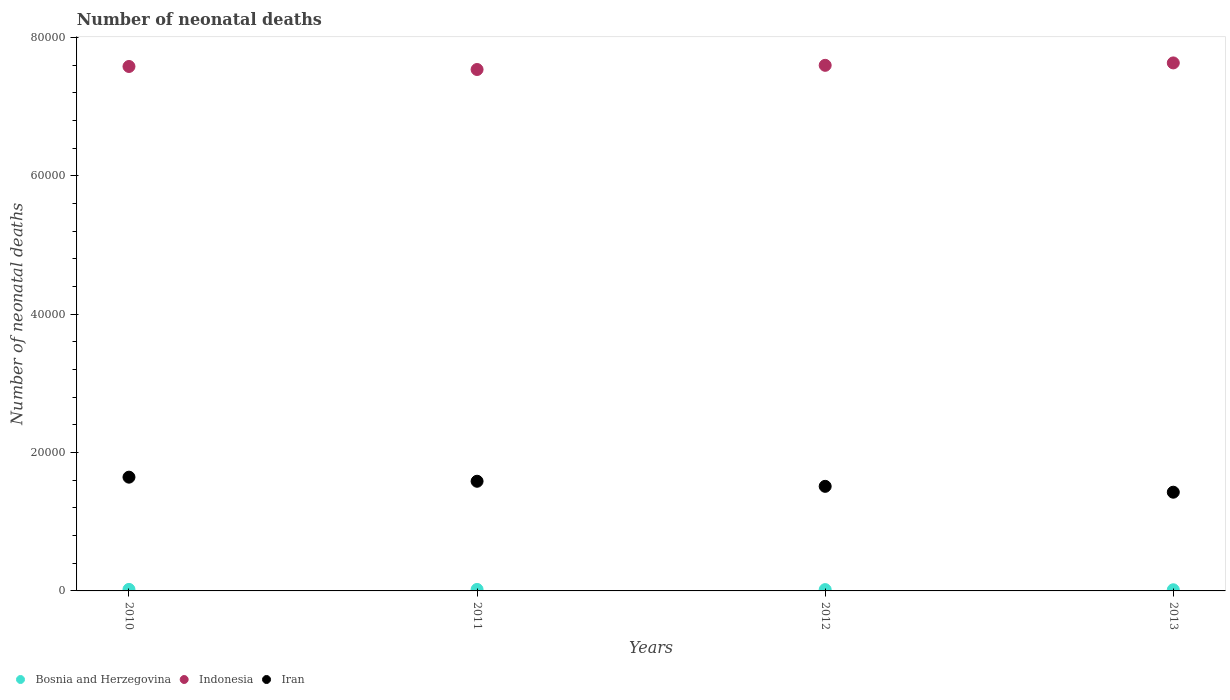How many different coloured dotlines are there?
Provide a succinct answer. 3. What is the number of neonatal deaths in in Iran in 2012?
Offer a terse response. 1.51e+04. Across all years, what is the maximum number of neonatal deaths in in Iran?
Make the answer very short. 1.64e+04. Across all years, what is the minimum number of neonatal deaths in in Iran?
Keep it short and to the point. 1.43e+04. In which year was the number of neonatal deaths in in Iran minimum?
Provide a succinct answer. 2013. What is the total number of neonatal deaths in in Iran in the graph?
Ensure brevity in your answer.  6.17e+04. What is the difference between the number of neonatal deaths in in Iran in 2010 and that in 2013?
Your answer should be very brief. 2174. What is the difference between the number of neonatal deaths in in Bosnia and Herzegovina in 2011 and the number of neonatal deaths in in Iran in 2012?
Provide a succinct answer. -1.49e+04. What is the average number of neonatal deaths in in Bosnia and Herzegovina per year?
Provide a succinct answer. 198.5. In the year 2012, what is the difference between the number of neonatal deaths in in Indonesia and number of neonatal deaths in in Bosnia and Herzegovina?
Ensure brevity in your answer.  7.58e+04. In how many years, is the number of neonatal deaths in in Indonesia greater than 48000?
Offer a very short reply. 4. What is the ratio of the number of neonatal deaths in in Indonesia in 2011 to that in 2012?
Your answer should be very brief. 0.99. Is the number of neonatal deaths in in Bosnia and Herzegovina in 2010 less than that in 2012?
Your answer should be very brief. No. What is the difference between the highest and the second highest number of neonatal deaths in in Iran?
Your answer should be very brief. 592. What is the difference between the highest and the lowest number of neonatal deaths in in Indonesia?
Your answer should be compact. 951. In how many years, is the number of neonatal deaths in in Indonesia greater than the average number of neonatal deaths in in Indonesia taken over all years?
Offer a very short reply. 2. Is the sum of the number of neonatal deaths in in Bosnia and Herzegovina in 2012 and 2013 greater than the maximum number of neonatal deaths in in Iran across all years?
Ensure brevity in your answer.  No. Is it the case that in every year, the sum of the number of neonatal deaths in in Bosnia and Herzegovina and number of neonatal deaths in in Indonesia  is greater than the number of neonatal deaths in in Iran?
Keep it short and to the point. Yes. Is the number of neonatal deaths in in Bosnia and Herzegovina strictly greater than the number of neonatal deaths in in Indonesia over the years?
Ensure brevity in your answer.  No. How many years are there in the graph?
Offer a terse response. 4. What is the difference between two consecutive major ticks on the Y-axis?
Provide a succinct answer. 2.00e+04. Are the values on the major ticks of Y-axis written in scientific E-notation?
Ensure brevity in your answer.  No. Where does the legend appear in the graph?
Keep it short and to the point. Bottom left. How many legend labels are there?
Offer a terse response. 3. What is the title of the graph?
Provide a succinct answer. Number of neonatal deaths. What is the label or title of the X-axis?
Your response must be concise. Years. What is the label or title of the Y-axis?
Offer a terse response. Number of neonatal deaths. What is the Number of neonatal deaths of Bosnia and Herzegovina in 2010?
Your response must be concise. 220. What is the Number of neonatal deaths of Indonesia in 2010?
Your answer should be very brief. 7.58e+04. What is the Number of neonatal deaths of Iran in 2010?
Your answer should be very brief. 1.64e+04. What is the Number of neonatal deaths in Bosnia and Herzegovina in 2011?
Provide a succinct answer. 215. What is the Number of neonatal deaths of Indonesia in 2011?
Provide a succinct answer. 7.54e+04. What is the Number of neonatal deaths in Iran in 2011?
Make the answer very short. 1.58e+04. What is the Number of neonatal deaths of Bosnia and Herzegovina in 2012?
Keep it short and to the point. 192. What is the Number of neonatal deaths of Indonesia in 2012?
Ensure brevity in your answer.  7.60e+04. What is the Number of neonatal deaths in Iran in 2012?
Provide a short and direct response. 1.51e+04. What is the Number of neonatal deaths in Bosnia and Herzegovina in 2013?
Your answer should be compact. 167. What is the Number of neonatal deaths of Indonesia in 2013?
Ensure brevity in your answer.  7.63e+04. What is the Number of neonatal deaths in Iran in 2013?
Keep it short and to the point. 1.43e+04. Across all years, what is the maximum Number of neonatal deaths of Bosnia and Herzegovina?
Provide a short and direct response. 220. Across all years, what is the maximum Number of neonatal deaths in Indonesia?
Ensure brevity in your answer.  7.63e+04. Across all years, what is the maximum Number of neonatal deaths of Iran?
Offer a very short reply. 1.64e+04. Across all years, what is the minimum Number of neonatal deaths of Bosnia and Herzegovina?
Ensure brevity in your answer.  167. Across all years, what is the minimum Number of neonatal deaths of Indonesia?
Provide a short and direct response. 7.54e+04. Across all years, what is the minimum Number of neonatal deaths of Iran?
Give a very brief answer. 1.43e+04. What is the total Number of neonatal deaths in Bosnia and Herzegovina in the graph?
Ensure brevity in your answer.  794. What is the total Number of neonatal deaths of Indonesia in the graph?
Your response must be concise. 3.03e+05. What is the total Number of neonatal deaths of Iran in the graph?
Ensure brevity in your answer.  6.17e+04. What is the difference between the Number of neonatal deaths of Indonesia in 2010 and that in 2011?
Offer a very short reply. 436. What is the difference between the Number of neonatal deaths of Iran in 2010 and that in 2011?
Ensure brevity in your answer.  592. What is the difference between the Number of neonatal deaths of Indonesia in 2010 and that in 2012?
Your answer should be compact. -167. What is the difference between the Number of neonatal deaths in Iran in 2010 and that in 2012?
Provide a short and direct response. 1326. What is the difference between the Number of neonatal deaths of Indonesia in 2010 and that in 2013?
Ensure brevity in your answer.  -515. What is the difference between the Number of neonatal deaths of Iran in 2010 and that in 2013?
Provide a short and direct response. 2174. What is the difference between the Number of neonatal deaths of Indonesia in 2011 and that in 2012?
Offer a very short reply. -603. What is the difference between the Number of neonatal deaths of Iran in 2011 and that in 2012?
Offer a terse response. 734. What is the difference between the Number of neonatal deaths in Bosnia and Herzegovina in 2011 and that in 2013?
Make the answer very short. 48. What is the difference between the Number of neonatal deaths of Indonesia in 2011 and that in 2013?
Your response must be concise. -951. What is the difference between the Number of neonatal deaths of Iran in 2011 and that in 2013?
Ensure brevity in your answer.  1582. What is the difference between the Number of neonatal deaths in Bosnia and Herzegovina in 2012 and that in 2013?
Ensure brevity in your answer.  25. What is the difference between the Number of neonatal deaths of Indonesia in 2012 and that in 2013?
Offer a terse response. -348. What is the difference between the Number of neonatal deaths of Iran in 2012 and that in 2013?
Provide a succinct answer. 848. What is the difference between the Number of neonatal deaths in Bosnia and Herzegovina in 2010 and the Number of neonatal deaths in Indonesia in 2011?
Make the answer very short. -7.51e+04. What is the difference between the Number of neonatal deaths of Bosnia and Herzegovina in 2010 and the Number of neonatal deaths of Iran in 2011?
Your answer should be compact. -1.56e+04. What is the difference between the Number of neonatal deaths of Indonesia in 2010 and the Number of neonatal deaths of Iran in 2011?
Your response must be concise. 5.99e+04. What is the difference between the Number of neonatal deaths in Bosnia and Herzegovina in 2010 and the Number of neonatal deaths in Indonesia in 2012?
Keep it short and to the point. -7.57e+04. What is the difference between the Number of neonatal deaths of Bosnia and Herzegovina in 2010 and the Number of neonatal deaths of Iran in 2012?
Offer a terse response. -1.49e+04. What is the difference between the Number of neonatal deaths in Indonesia in 2010 and the Number of neonatal deaths in Iran in 2012?
Give a very brief answer. 6.07e+04. What is the difference between the Number of neonatal deaths in Bosnia and Herzegovina in 2010 and the Number of neonatal deaths in Indonesia in 2013?
Ensure brevity in your answer.  -7.61e+04. What is the difference between the Number of neonatal deaths of Bosnia and Herzegovina in 2010 and the Number of neonatal deaths of Iran in 2013?
Offer a terse response. -1.40e+04. What is the difference between the Number of neonatal deaths of Indonesia in 2010 and the Number of neonatal deaths of Iran in 2013?
Keep it short and to the point. 6.15e+04. What is the difference between the Number of neonatal deaths in Bosnia and Herzegovina in 2011 and the Number of neonatal deaths in Indonesia in 2012?
Offer a very short reply. -7.57e+04. What is the difference between the Number of neonatal deaths of Bosnia and Herzegovina in 2011 and the Number of neonatal deaths of Iran in 2012?
Make the answer very short. -1.49e+04. What is the difference between the Number of neonatal deaths in Indonesia in 2011 and the Number of neonatal deaths in Iran in 2012?
Your answer should be very brief. 6.02e+04. What is the difference between the Number of neonatal deaths in Bosnia and Herzegovina in 2011 and the Number of neonatal deaths in Indonesia in 2013?
Your answer should be compact. -7.61e+04. What is the difference between the Number of neonatal deaths of Bosnia and Herzegovina in 2011 and the Number of neonatal deaths of Iran in 2013?
Ensure brevity in your answer.  -1.41e+04. What is the difference between the Number of neonatal deaths of Indonesia in 2011 and the Number of neonatal deaths of Iran in 2013?
Provide a succinct answer. 6.11e+04. What is the difference between the Number of neonatal deaths in Bosnia and Herzegovina in 2012 and the Number of neonatal deaths in Indonesia in 2013?
Offer a terse response. -7.61e+04. What is the difference between the Number of neonatal deaths in Bosnia and Herzegovina in 2012 and the Number of neonatal deaths in Iran in 2013?
Keep it short and to the point. -1.41e+04. What is the difference between the Number of neonatal deaths in Indonesia in 2012 and the Number of neonatal deaths in Iran in 2013?
Keep it short and to the point. 6.17e+04. What is the average Number of neonatal deaths of Bosnia and Herzegovina per year?
Offer a very short reply. 198.5. What is the average Number of neonatal deaths in Indonesia per year?
Offer a very short reply. 7.59e+04. What is the average Number of neonatal deaths in Iran per year?
Give a very brief answer. 1.54e+04. In the year 2010, what is the difference between the Number of neonatal deaths in Bosnia and Herzegovina and Number of neonatal deaths in Indonesia?
Your response must be concise. -7.56e+04. In the year 2010, what is the difference between the Number of neonatal deaths in Bosnia and Herzegovina and Number of neonatal deaths in Iran?
Make the answer very short. -1.62e+04. In the year 2010, what is the difference between the Number of neonatal deaths in Indonesia and Number of neonatal deaths in Iran?
Ensure brevity in your answer.  5.94e+04. In the year 2011, what is the difference between the Number of neonatal deaths in Bosnia and Herzegovina and Number of neonatal deaths in Indonesia?
Offer a terse response. -7.51e+04. In the year 2011, what is the difference between the Number of neonatal deaths in Bosnia and Herzegovina and Number of neonatal deaths in Iran?
Offer a terse response. -1.56e+04. In the year 2011, what is the difference between the Number of neonatal deaths in Indonesia and Number of neonatal deaths in Iran?
Ensure brevity in your answer.  5.95e+04. In the year 2012, what is the difference between the Number of neonatal deaths of Bosnia and Herzegovina and Number of neonatal deaths of Indonesia?
Keep it short and to the point. -7.58e+04. In the year 2012, what is the difference between the Number of neonatal deaths of Bosnia and Herzegovina and Number of neonatal deaths of Iran?
Offer a very short reply. -1.49e+04. In the year 2012, what is the difference between the Number of neonatal deaths of Indonesia and Number of neonatal deaths of Iran?
Your answer should be very brief. 6.08e+04. In the year 2013, what is the difference between the Number of neonatal deaths of Bosnia and Herzegovina and Number of neonatal deaths of Indonesia?
Your answer should be very brief. -7.61e+04. In the year 2013, what is the difference between the Number of neonatal deaths in Bosnia and Herzegovina and Number of neonatal deaths in Iran?
Keep it short and to the point. -1.41e+04. In the year 2013, what is the difference between the Number of neonatal deaths in Indonesia and Number of neonatal deaths in Iran?
Your response must be concise. 6.20e+04. What is the ratio of the Number of neonatal deaths in Bosnia and Herzegovina in 2010 to that in 2011?
Make the answer very short. 1.02. What is the ratio of the Number of neonatal deaths in Iran in 2010 to that in 2011?
Ensure brevity in your answer.  1.04. What is the ratio of the Number of neonatal deaths of Bosnia and Herzegovina in 2010 to that in 2012?
Your answer should be very brief. 1.15. What is the ratio of the Number of neonatal deaths in Indonesia in 2010 to that in 2012?
Provide a short and direct response. 1. What is the ratio of the Number of neonatal deaths of Iran in 2010 to that in 2012?
Keep it short and to the point. 1.09. What is the ratio of the Number of neonatal deaths in Bosnia and Herzegovina in 2010 to that in 2013?
Offer a terse response. 1.32. What is the ratio of the Number of neonatal deaths of Indonesia in 2010 to that in 2013?
Your answer should be compact. 0.99. What is the ratio of the Number of neonatal deaths in Iran in 2010 to that in 2013?
Give a very brief answer. 1.15. What is the ratio of the Number of neonatal deaths of Bosnia and Herzegovina in 2011 to that in 2012?
Your answer should be compact. 1.12. What is the ratio of the Number of neonatal deaths of Indonesia in 2011 to that in 2012?
Ensure brevity in your answer.  0.99. What is the ratio of the Number of neonatal deaths in Iran in 2011 to that in 2012?
Your response must be concise. 1.05. What is the ratio of the Number of neonatal deaths of Bosnia and Herzegovina in 2011 to that in 2013?
Offer a very short reply. 1.29. What is the ratio of the Number of neonatal deaths in Indonesia in 2011 to that in 2013?
Offer a very short reply. 0.99. What is the ratio of the Number of neonatal deaths in Iran in 2011 to that in 2013?
Ensure brevity in your answer.  1.11. What is the ratio of the Number of neonatal deaths of Bosnia and Herzegovina in 2012 to that in 2013?
Your answer should be compact. 1.15. What is the ratio of the Number of neonatal deaths of Indonesia in 2012 to that in 2013?
Keep it short and to the point. 1. What is the ratio of the Number of neonatal deaths of Iran in 2012 to that in 2013?
Make the answer very short. 1.06. What is the difference between the highest and the second highest Number of neonatal deaths of Indonesia?
Make the answer very short. 348. What is the difference between the highest and the second highest Number of neonatal deaths in Iran?
Your answer should be very brief. 592. What is the difference between the highest and the lowest Number of neonatal deaths in Indonesia?
Keep it short and to the point. 951. What is the difference between the highest and the lowest Number of neonatal deaths of Iran?
Offer a terse response. 2174. 